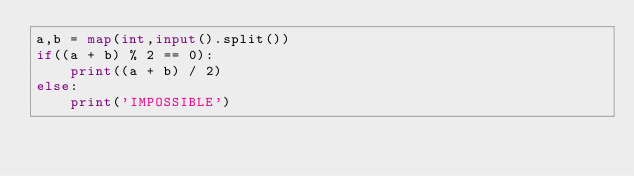Convert code to text. <code><loc_0><loc_0><loc_500><loc_500><_Python_>a,b = map(int,input().split())
if((a + b) % 2 == 0):
    print((a + b) / 2)
else:
    print('IMPOSSIBLE')</code> 